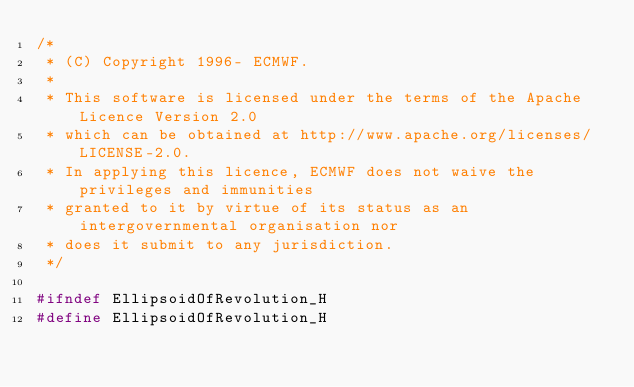Convert code to text. <code><loc_0><loc_0><loc_500><loc_500><_C_>/*
 * (C) Copyright 1996- ECMWF.
 *
 * This software is licensed under the terms of the Apache Licence Version 2.0
 * which can be obtained at http://www.apache.org/licenses/LICENSE-2.0.
 * In applying this licence, ECMWF does not waive the privileges and immunities
 * granted to it by virtue of its status as an intergovernmental organisation nor
 * does it submit to any jurisdiction.
 */

#ifndef EllipsoidOfRevolution_H
#define EllipsoidOfRevolution_H
</code> 